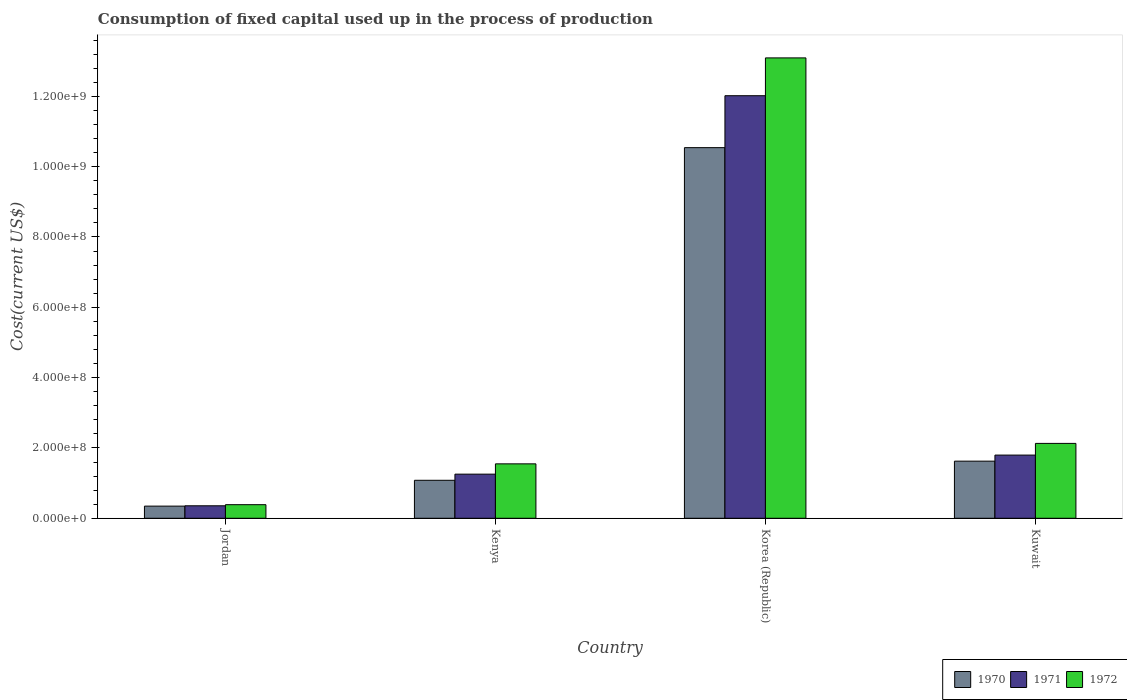How many groups of bars are there?
Keep it short and to the point. 4. Are the number of bars on each tick of the X-axis equal?
Give a very brief answer. Yes. How many bars are there on the 2nd tick from the left?
Keep it short and to the point. 3. How many bars are there on the 2nd tick from the right?
Offer a terse response. 3. What is the label of the 2nd group of bars from the left?
Provide a short and direct response. Kenya. In how many cases, is the number of bars for a given country not equal to the number of legend labels?
Ensure brevity in your answer.  0. What is the amount consumed in the process of production in 1970 in Jordan?
Offer a very short reply. 3.46e+07. Across all countries, what is the maximum amount consumed in the process of production in 1972?
Ensure brevity in your answer.  1.31e+09. Across all countries, what is the minimum amount consumed in the process of production in 1971?
Ensure brevity in your answer.  3.55e+07. In which country was the amount consumed in the process of production in 1971 maximum?
Make the answer very short. Korea (Republic). In which country was the amount consumed in the process of production in 1971 minimum?
Offer a very short reply. Jordan. What is the total amount consumed in the process of production in 1972 in the graph?
Your response must be concise. 1.72e+09. What is the difference between the amount consumed in the process of production in 1972 in Jordan and that in Kenya?
Offer a very short reply. -1.16e+08. What is the difference between the amount consumed in the process of production in 1970 in Kenya and the amount consumed in the process of production in 1971 in Korea (Republic)?
Your answer should be very brief. -1.09e+09. What is the average amount consumed in the process of production in 1970 per country?
Provide a short and direct response. 3.40e+08. What is the difference between the amount consumed in the process of production of/in 1971 and amount consumed in the process of production of/in 1970 in Kuwait?
Provide a succinct answer. 1.73e+07. In how many countries, is the amount consumed in the process of production in 1970 greater than 120000000 US$?
Offer a terse response. 2. What is the ratio of the amount consumed in the process of production in 1970 in Kenya to that in Korea (Republic)?
Offer a very short reply. 0.1. Is the difference between the amount consumed in the process of production in 1971 in Jordan and Korea (Republic) greater than the difference between the amount consumed in the process of production in 1970 in Jordan and Korea (Republic)?
Keep it short and to the point. No. What is the difference between the highest and the second highest amount consumed in the process of production in 1971?
Provide a short and direct response. -1.08e+09. What is the difference between the highest and the lowest amount consumed in the process of production in 1971?
Make the answer very short. 1.17e+09. In how many countries, is the amount consumed in the process of production in 1972 greater than the average amount consumed in the process of production in 1972 taken over all countries?
Provide a short and direct response. 1. What does the 1st bar from the left in Korea (Republic) represents?
Your answer should be compact. 1970. What does the 1st bar from the right in Kenya represents?
Offer a terse response. 1972. How many bars are there?
Your response must be concise. 12. How many countries are there in the graph?
Keep it short and to the point. 4. Does the graph contain any zero values?
Your answer should be compact. No. Does the graph contain grids?
Make the answer very short. No. Where does the legend appear in the graph?
Provide a succinct answer. Bottom right. How are the legend labels stacked?
Offer a terse response. Horizontal. What is the title of the graph?
Offer a very short reply. Consumption of fixed capital used up in the process of production. Does "1974" appear as one of the legend labels in the graph?
Make the answer very short. No. What is the label or title of the Y-axis?
Offer a very short reply. Cost(current US$). What is the Cost(current US$) of 1970 in Jordan?
Provide a short and direct response. 3.46e+07. What is the Cost(current US$) in 1971 in Jordan?
Provide a succinct answer. 3.55e+07. What is the Cost(current US$) of 1972 in Jordan?
Offer a very short reply. 3.86e+07. What is the Cost(current US$) in 1970 in Kenya?
Make the answer very short. 1.08e+08. What is the Cost(current US$) in 1971 in Kenya?
Ensure brevity in your answer.  1.25e+08. What is the Cost(current US$) of 1972 in Kenya?
Your response must be concise. 1.55e+08. What is the Cost(current US$) of 1970 in Korea (Republic)?
Provide a succinct answer. 1.05e+09. What is the Cost(current US$) in 1971 in Korea (Republic)?
Offer a terse response. 1.20e+09. What is the Cost(current US$) of 1972 in Korea (Republic)?
Provide a short and direct response. 1.31e+09. What is the Cost(current US$) of 1970 in Kuwait?
Provide a short and direct response. 1.62e+08. What is the Cost(current US$) of 1971 in Kuwait?
Your response must be concise. 1.80e+08. What is the Cost(current US$) of 1972 in Kuwait?
Your answer should be compact. 2.13e+08. Across all countries, what is the maximum Cost(current US$) of 1970?
Make the answer very short. 1.05e+09. Across all countries, what is the maximum Cost(current US$) of 1971?
Keep it short and to the point. 1.20e+09. Across all countries, what is the maximum Cost(current US$) of 1972?
Offer a very short reply. 1.31e+09. Across all countries, what is the minimum Cost(current US$) in 1970?
Make the answer very short. 3.46e+07. Across all countries, what is the minimum Cost(current US$) of 1971?
Provide a succinct answer. 3.55e+07. Across all countries, what is the minimum Cost(current US$) of 1972?
Offer a terse response. 3.86e+07. What is the total Cost(current US$) in 1970 in the graph?
Your answer should be very brief. 1.36e+09. What is the total Cost(current US$) of 1971 in the graph?
Give a very brief answer. 1.54e+09. What is the total Cost(current US$) of 1972 in the graph?
Keep it short and to the point. 1.72e+09. What is the difference between the Cost(current US$) in 1970 in Jordan and that in Kenya?
Make the answer very short. -7.34e+07. What is the difference between the Cost(current US$) of 1971 in Jordan and that in Kenya?
Your answer should be very brief. -9.00e+07. What is the difference between the Cost(current US$) in 1972 in Jordan and that in Kenya?
Make the answer very short. -1.16e+08. What is the difference between the Cost(current US$) in 1970 in Jordan and that in Korea (Republic)?
Your answer should be compact. -1.02e+09. What is the difference between the Cost(current US$) of 1971 in Jordan and that in Korea (Republic)?
Your answer should be compact. -1.17e+09. What is the difference between the Cost(current US$) of 1972 in Jordan and that in Korea (Republic)?
Offer a terse response. -1.27e+09. What is the difference between the Cost(current US$) of 1970 in Jordan and that in Kuwait?
Keep it short and to the point. -1.28e+08. What is the difference between the Cost(current US$) in 1971 in Jordan and that in Kuwait?
Your answer should be compact. -1.44e+08. What is the difference between the Cost(current US$) in 1972 in Jordan and that in Kuwait?
Offer a very short reply. -1.74e+08. What is the difference between the Cost(current US$) in 1970 in Kenya and that in Korea (Republic)?
Your answer should be very brief. -9.46e+08. What is the difference between the Cost(current US$) in 1971 in Kenya and that in Korea (Republic)?
Offer a terse response. -1.08e+09. What is the difference between the Cost(current US$) in 1972 in Kenya and that in Korea (Republic)?
Make the answer very short. -1.15e+09. What is the difference between the Cost(current US$) in 1970 in Kenya and that in Kuwait?
Your answer should be very brief. -5.44e+07. What is the difference between the Cost(current US$) of 1971 in Kenya and that in Kuwait?
Offer a very short reply. -5.42e+07. What is the difference between the Cost(current US$) of 1972 in Kenya and that in Kuwait?
Keep it short and to the point. -5.82e+07. What is the difference between the Cost(current US$) in 1970 in Korea (Republic) and that in Kuwait?
Ensure brevity in your answer.  8.92e+08. What is the difference between the Cost(current US$) in 1971 in Korea (Republic) and that in Kuwait?
Offer a terse response. 1.02e+09. What is the difference between the Cost(current US$) in 1972 in Korea (Republic) and that in Kuwait?
Give a very brief answer. 1.10e+09. What is the difference between the Cost(current US$) of 1970 in Jordan and the Cost(current US$) of 1971 in Kenya?
Your response must be concise. -9.09e+07. What is the difference between the Cost(current US$) of 1970 in Jordan and the Cost(current US$) of 1972 in Kenya?
Offer a terse response. -1.20e+08. What is the difference between the Cost(current US$) in 1971 in Jordan and the Cost(current US$) in 1972 in Kenya?
Give a very brief answer. -1.19e+08. What is the difference between the Cost(current US$) in 1970 in Jordan and the Cost(current US$) in 1971 in Korea (Republic)?
Your answer should be compact. -1.17e+09. What is the difference between the Cost(current US$) of 1970 in Jordan and the Cost(current US$) of 1972 in Korea (Republic)?
Give a very brief answer. -1.27e+09. What is the difference between the Cost(current US$) in 1971 in Jordan and the Cost(current US$) in 1972 in Korea (Republic)?
Your response must be concise. -1.27e+09. What is the difference between the Cost(current US$) in 1970 in Jordan and the Cost(current US$) in 1971 in Kuwait?
Offer a very short reply. -1.45e+08. What is the difference between the Cost(current US$) of 1970 in Jordan and the Cost(current US$) of 1972 in Kuwait?
Provide a succinct answer. -1.78e+08. What is the difference between the Cost(current US$) in 1971 in Jordan and the Cost(current US$) in 1972 in Kuwait?
Your answer should be compact. -1.77e+08. What is the difference between the Cost(current US$) of 1970 in Kenya and the Cost(current US$) of 1971 in Korea (Republic)?
Make the answer very short. -1.09e+09. What is the difference between the Cost(current US$) of 1970 in Kenya and the Cost(current US$) of 1972 in Korea (Republic)?
Keep it short and to the point. -1.20e+09. What is the difference between the Cost(current US$) in 1971 in Kenya and the Cost(current US$) in 1972 in Korea (Republic)?
Your answer should be compact. -1.18e+09. What is the difference between the Cost(current US$) of 1970 in Kenya and the Cost(current US$) of 1971 in Kuwait?
Give a very brief answer. -7.17e+07. What is the difference between the Cost(current US$) in 1970 in Kenya and the Cost(current US$) in 1972 in Kuwait?
Provide a short and direct response. -1.05e+08. What is the difference between the Cost(current US$) of 1971 in Kenya and the Cost(current US$) of 1972 in Kuwait?
Your response must be concise. -8.75e+07. What is the difference between the Cost(current US$) in 1970 in Korea (Republic) and the Cost(current US$) in 1971 in Kuwait?
Offer a terse response. 8.74e+08. What is the difference between the Cost(current US$) in 1970 in Korea (Republic) and the Cost(current US$) in 1972 in Kuwait?
Make the answer very short. 8.41e+08. What is the difference between the Cost(current US$) in 1971 in Korea (Republic) and the Cost(current US$) in 1972 in Kuwait?
Offer a terse response. 9.89e+08. What is the average Cost(current US$) of 1970 per country?
Make the answer very short. 3.40e+08. What is the average Cost(current US$) of 1971 per country?
Give a very brief answer. 3.86e+08. What is the average Cost(current US$) in 1972 per country?
Your response must be concise. 4.29e+08. What is the difference between the Cost(current US$) in 1970 and Cost(current US$) in 1971 in Jordan?
Provide a short and direct response. -9.20e+05. What is the difference between the Cost(current US$) of 1970 and Cost(current US$) of 1972 in Jordan?
Provide a short and direct response. -4.07e+06. What is the difference between the Cost(current US$) of 1971 and Cost(current US$) of 1972 in Jordan?
Your answer should be compact. -3.15e+06. What is the difference between the Cost(current US$) in 1970 and Cost(current US$) in 1971 in Kenya?
Offer a terse response. -1.75e+07. What is the difference between the Cost(current US$) of 1970 and Cost(current US$) of 1972 in Kenya?
Keep it short and to the point. -4.68e+07. What is the difference between the Cost(current US$) of 1971 and Cost(current US$) of 1972 in Kenya?
Your answer should be compact. -2.93e+07. What is the difference between the Cost(current US$) of 1970 and Cost(current US$) of 1971 in Korea (Republic)?
Make the answer very short. -1.48e+08. What is the difference between the Cost(current US$) in 1970 and Cost(current US$) in 1972 in Korea (Republic)?
Your answer should be very brief. -2.55e+08. What is the difference between the Cost(current US$) of 1971 and Cost(current US$) of 1972 in Korea (Republic)?
Your answer should be very brief. -1.08e+08. What is the difference between the Cost(current US$) of 1970 and Cost(current US$) of 1971 in Kuwait?
Your answer should be compact. -1.73e+07. What is the difference between the Cost(current US$) of 1970 and Cost(current US$) of 1972 in Kuwait?
Keep it short and to the point. -5.05e+07. What is the difference between the Cost(current US$) in 1971 and Cost(current US$) in 1972 in Kuwait?
Keep it short and to the point. -3.32e+07. What is the ratio of the Cost(current US$) in 1970 in Jordan to that in Kenya?
Make the answer very short. 0.32. What is the ratio of the Cost(current US$) of 1971 in Jordan to that in Kenya?
Keep it short and to the point. 0.28. What is the ratio of the Cost(current US$) in 1972 in Jordan to that in Kenya?
Offer a terse response. 0.25. What is the ratio of the Cost(current US$) of 1970 in Jordan to that in Korea (Republic)?
Your answer should be compact. 0.03. What is the ratio of the Cost(current US$) of 1971 in Jordan to that in Korea (Republic)?
Your response must be concise. 0.03. What is the ratio of the Cost(current US$) in 1972 in Jordan to that in Korea (Republic)?
Make the answer very short. 0.03. What is the ratio of the Cost(current US$) in 1970 in Jordan to that in Kuwait?
Your answer should be very brief. 0.21. What is the ratio of the Cost(current US$) of 1971 in Jordan to that in Kuwait?
Keep it short and to the point. 0.2. What is the ratio of the Cost(current US$) of 1972 in Jordan to that in Kuwait?
Give a very brief answer. 0.18. What is the ratio of the Cost(current US$) in 1970 in Kenya to that in Korea (Republic)?
Make the answer very short. 0.1. What is the ratio of the Cost(current US$) in 1971 in Kenya to that in Korea (Republic)?
Your response must be concise. 0.1. What is the ratio of the Cost(current US$) in 1972 in Kenya to that in Korea (Republic)?
Your answer should be compact. 0.12. What is the ratio of the Cost(current US$) in 1970 in Kenya to that in Kuwait?
Give a very brief answer. 0.66. What is the ratio of the Cost(current US$) in 1971 in Kenya to that in Kuwait?
Make the answer very short. 0.7. What is the ratio of the Cost(current US$) of 1972 in Kenya to that in Kuwait?
Offer a terse response. 0.73. What is the ratio of the Cost(current US$) of 1970 in Korea (Republic) to that in Kuwait?
Provide a short and direct response. 6.49. What is the ratio of the Cost(current US$) in 1971 in Korea (Republic) to that in Kuwait?
Provide a short and direct response. 6.69. What is the ratio of the Cost(current US$) in 1972 in Korea (Republic) to that in Kuwait?
Give a very brief answer. 6.15. What is the difference between the highest and the second highest Cost(current US$) of 1970?
Your answer should be compact. 8.92e+08. What is the difference between the highest and the second highest Cost(current US$) of 1971?
Offer a very short reply. 1.02e+09. What is the difference between the highest and the second highest Cost(current US$) in 1972?
Your answer should be compact. 1.10e+09. What is the difference between the highest and the lowest Cost(current US$) of 1970?
Ensure brevity in your answer.  1.02e+09. What is the difference between the highest and the lowest Cost(current US$) in 1971?
Keep it short and to the point. 1.17e+09. What is the difference between the highest and the lowest Cost(current US$) in 1972?
Your answer should be compact. 1.27e+09. 